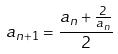Convert formula to latex. <formula><loc_0><loc_0><loc_500><loc_500>a _ { n + 1 } = \frac { a _ { n } + \frac { 2 } { a _ { n } } } { 2 }</formula> 